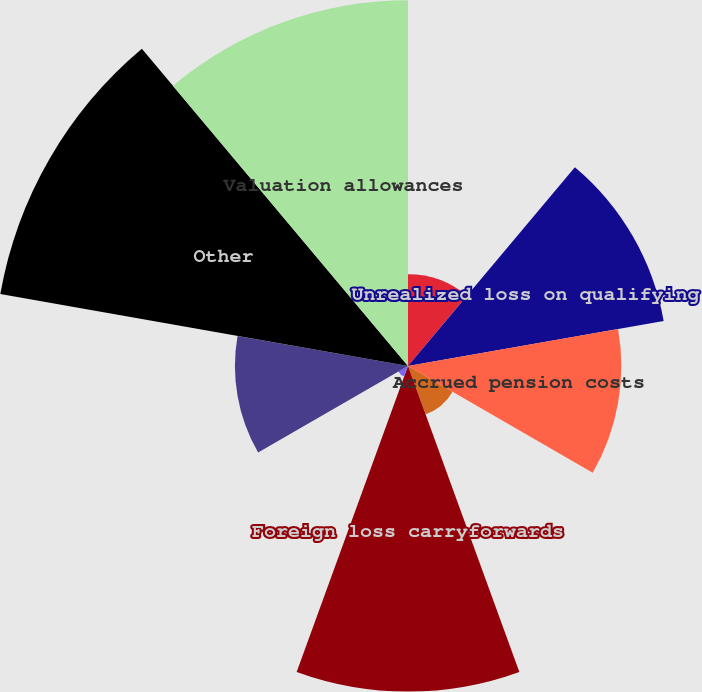<chart> <loc_0><loc_0><loc_500><loc_500><pie_chart><fcel>NUG contracts and buybacks<fcel>Unrealized loss on qualifying<fcel>Accrued pension costs<fcel>Federal tax credit<fcel>Foreign loss carryforwards<fcel>Foreign - other<fcel>Contributions in aid of<fcel>Other<fcel>Valuation allowances<nl><fcel>4.82%<fcel>13.62%<fcel>11.19%<fcel>2.7%<fcel>17.08%<fcel>0.59%<fcel>9.08%<fcel>21.72%<fcel>19.19%<nl></chart> 